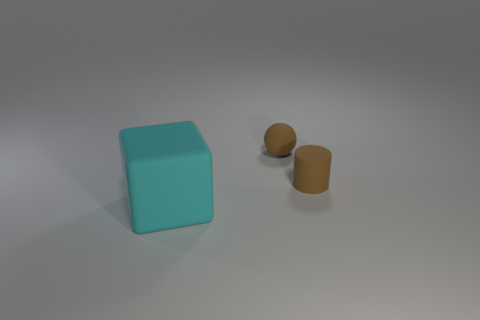Add 3 purple balls. How many objects exist? 6 Subtract all balls. How many objects are left? 2 Add 3 small balls. How many small balls are left? 4 Add 3 small brown balls. How many small brown balls exist? 4 Subtract 0 yellow blocks. How many objects are left? 3 Subtract all brown rubber cylinders. Subtract all spheres. How many objects are left? 1 